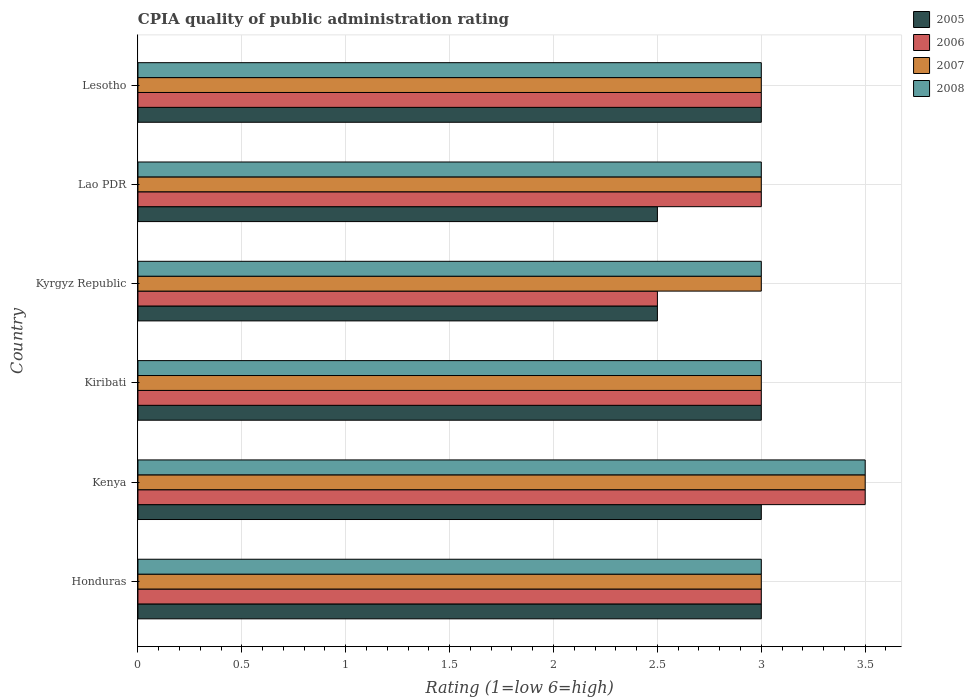How many different coloured bars are there?
Offer a terse response. 4. How many groups of bars are there?
Your answer should be compact. 6. Are the number of bars on each tick of the Y-axis equal?
Your response must be concise. Yes. How many bars are there on the 2nd tick from the top?
Give a very brief answer. 4. How many bars are there on the 2nd tick from the bottom?
Offer a very short reply. 4. What is the label of the 3rd group of bars from the top?
Offer a very short reply. Kyrgyz Republic. In how many cases, is the number of bars for a given country not equal to the number of legend labels?
Your answer should be compact. 0. Across all countries, what is the maximum CPIA rating in 2007?
Provide a short and direct response. 3.5. Across all countries, what is the minimum CPIA rating in 2008?
Your answer should be very brief. 3. In which country was the CPIA rating in 2006 maximum?
Ensure brevity in your answer.  Kenya. In which country was the CPIA rating in 2007 minimum?
Offer a terse response. Honduras. What is the total CPIA rating in 2007 in the graph?
Give a very brief answer. 18.5. What is the difference between the CPIA rating in 2008 in Honduras and the CPIA rating in 2005 in Lesotho?
Give a very brief answer. 0. What is the average CPIA rating in 2005 per country?
Give a very brief answer. 2.83. What is the difference between the CPIA rating in 2005 and CPIA rating in 2007 in Lao PDR?
Keep it short and to the point. -0.5. What is the ratio of the CPIA rating in 2006 in Honduras to that in Kenya?
Provide a short and direct response. 0.86. Is the difference between the CPIA rating in 2005 in Kenya and Kyrgyz Republic greater than the difference between the CPIA rating in 2007 in Kenya and Kyrgyz Republic?
Provide a succinct answer. No. What is the difference between the highest and the second highest CPIA rating in 2005?
Ensure brevity in your answer.  0. In how many countries, is the CPIA rating in 2005 greater than the average CPIA rating in 2005 taken over all countries?
Ensure brevity in your answer.  4. Is it the case that in every country, the sum of the CPIA rating in 2005 and CPIA rating in 2008 is greater than the sum of CPIA rating in 2006 and CPIA rating in 2007?
Offer a terse response. No. What does the 3rd bar from the top in Honduras represents?
Provide a succinct answer. 2006. Are all the bars in the graph horizontal?
Give a very brief answer. Yes. Are the values on the major ticks of X-axis written in scientific E-notation?
Keep it short and to the point. No. Does the graph contain any zero values?
Keep it short and to the point. No. How are the legend labels stacked?
Your answer should be very brief. Vertical. What is the title of the graph?
Offer a terse response. CPIA quality of public administration rating. What is the label or title of the Y-axis?
Keep it short and to the point. Country. What is the Rating (1=low 6=high) in 2006 in Honduras?
Provide a succinct answer. 3. What is the Rating (1=low 6=high) in 2007 in Kenya?
Your answer should be compact. 3.5. What is the Rating (1=low 6=high) of 2008 in Kenya?
Offer a very short reply. 3.5. What is the Rating (1=low 6=high) in 2006 in Kiribati?
Make the answer very short. 3. What is the Rating (1=low 6=high) in 2007 in Kiribati?
Your answer should be compact. 3. What is the Rating (1=low 6=high) of 2008 in Kyrgyz Republic?
Your answer should be very brief. 3. What is the Rating (1=low 6=high) in 2005 in Lao PDR?
Offer a very short reply. 2.5. What is the Rating (1=low 6=high) of 2006 in Lao PDR?
Your answer should be compact. 3. What is the Rating (1=low 6=high) of 2007 in Lesotho?
Your answer should be compact. 3. Across all countries, what is the minimum Rating (1=low 6=high) of 2006?
Your answer should be very brief. 2.5. Across all countries, what is the minimum Rating (1=low 6=high) in 2007?
Provide a succinct answer. 3. Across all countries, what is the minimum Rating (1=low 6=high) in 2008?
Give a very brief answer. 3. What is the total Rating (1=low 6=high) in 2005 in the graph?
Keep it short and to the point. 17. What is the difference between the Rating (1=low 6=high) in 2007 in Honduras and that in Kenya?
Keep it short and to the point. -0.5. What is the difference between the Rating (1=low 6=high) in 2007 in Honduras and that in Kiribati?
Your answer should be compact. 0. What is the difference between the Rating (1=low 6=high) of 2008 in Honduras and that in Kiribati?
Provide a succinct answer. 0. What is the difference between the Rating (1=low 6=high) of 2005 in Honduras and that in Kyrgyz Republic?
Keep it short and to the point. 0.5. What is the difference between the Rating (1=low 6=high) in 2007 in Honduras and that in Kyrgyz Republic?
Offer a terse response. 0. What is the difference between the Rating (1=low 6=high) of 2008 in Honduras and that in Kyrgyz Republic?
Provide a short and direct response. 0. What is the difference between the Rating (1=low 6=high) in 2005 in Honduras and that in Lao PDR?
Offer a very short reply. 0.5. What is the difference between the Rating (1=low 6=high) in 2006 in Honduras and that in Lao PDR?
Offer a terse response. 0. What is the difference between the Rating (1=low 6=high) of 2007 in Honduras and that in Lao PDR?
Give a very brief answer. 0. What is the difference between the Rating (1=low 6=high) in 2007 in Honduras and that in Lesotho?
Offer a very short reply. 0. What is the difference between the Rating (1=low 6=high) of 2005 in Kenya and that in Kiribati?
Make the answer very short. 0. What is the difference between the Rating (1=low 6=high) in 2008 in Kenya and that in Kyrgyz Republic?
Offer a terse response. 0.5. What is the difference between the Rating (1=low 6=high) in 2005 in Kenya and that in Lesotho?
Offer a terse response. 0. What is the difference between the Rating (1=low 6=high) of 2005 in Kiribati and that in Kyrgyz Republic?
Provide a succinct answer. 0.5. What is the difference between the Rating (1=low 6=high) in 2006 in Kiribati and that in Kyrgyz Republic?
Keep it short and to the point. 0.5. What is the difference between the Rating (1=low 6=high) of 2006 in Kiribati and that in Lao PDR?
Your answer should be compact. 0. What is the difference between the Rating (1=low 6=high) in 2008 in Kiribati and that in Lao PDR?
Offer a terse response. 0. What is the difference between the Rating (1=low 6=high) in 2005 in Kiribati and that in Lesotho?
Your answer should be very brief. 0. What is the difference between the Rating (1=low 6=high) of 2006 in Kiribati and that in Lesotho?
Give a very brief answer. 0. What is the difference between the Rating (1=low 6=high) of 2005 in Kyrgyz Republic and that in Lao PDR?
Ensure brevity in your answer.  0. What is the difference between the Rating (1=low 6=high) in 2007 in Kyrgyz Republic and that in Lao PDR?
Offer a very short reply. 0. What is the difference between the Rating (1=low 6=high) of 2005 in Kyrgyz Republic and that in Lesotho?
Give a very brief answer. -0.5. What is the difference between the Rating (1=low 6=high) of 2005 in Honduras and the Rating (1=low 6=high) of 2006 in Kenya?
Make the answer very short. -0.5. What is the difference between the Rating (1=low 6=high) in 2005 in Honduras and the Rating (1=low 6=high) in 2007 in Kenya?
Your answer should be very brief. -0.5. What is the difference between the Rating (1=low 6=high) in 2006 in Honduras and the Rating (1=low 6=high) in 2007 in Kenya?
Offer a very short reply. -0.5. What is the difference between the Rating (1=low 6=high) of 2007 in Honduras and the Rating (1=low 6=high) of 2008 in Kiribati?
Make the answer very short. 0. What is the difference between the Rating (1=low 6=high) in 2005 in Honduras and the Rating (1=low 6=high) in 2006 in Kyrgyz Republic?
Your answer should be very brief. 0.5. What is the difference between the Rating (1=low 6=high) of 2006 in Honduras and the Rating (1=low 6=high) of 2008 in Kyrgyz Republic?
Your response must be concise. 0. What is the difference between the Rating (1=low 6=high) of 2006 in Honduras and the Rating (1=low 6=high) of 2008 in Lao PDR?
Your response must be concise. 0. What is the difference between the Rating (1=low 6=high) of 2007 in Honduras and the Rating (1=low 6=high) of 2008 in Lao PDR?
Your answer should be compact. 0. What is the difference between the Rating (1=low 6=high) of 2005 in Honduras and the Rating (1=low 6=high) of 2006 in Lesotho?
Your answer should be very brief. 0. What is the difference between the Rating (1=low 6=high) of 2005 in Honduras and the Rating (1=low 6=high) of 2007 in Lesotho?
Make the answer very short. 0. What is the difference between the Rating (1=low 6=high) of 2005 in Honduras and the Rating (1=low 6=high) of 2008 in Lesotho?
Ensure brevity in your answer.  0. What is the difference between the Rating (1=low 6=high) in 2006 in Honduras and the Rating (1=low 6=high) in 2007 in Lesotho?
Ensure brevity in your answer.  0. What is the difference between the Rating (1=low 6=high) of 2006 in Honduras and the Rating (1=low 6=high) of 2008 in Lesotho?
Give a very brief answer. 0. What is the difference between the Rating (1=low 6=high) in 2007 in Honduras and the Rating (1=low 6=high) in 2008 in Lesotho?
Provide a short and direct response. 0. What is the difference between the Rating (1=low 6=high) of 2005 in Kenya and the Rating (1=low 6=high) of 2008 in Kiribati?
Provide a succinct answer. 0. What is the difference between the Rating (1=low 6=high) in 2005 in Kenya and the Rating (1=low 6=high) in 2006 in Kyrgyz Republic?
Offer a terse response. 0.5. What is the difference between the Rating (1=low 6=high) of 2005 in Kenya and the Rating (1=low 6=high) of 2007 in Kyrgyz Republic?
Your answer should be very brief. 0. What is the difference between the Rating (1=low 6=high) in 2005 in Kenya and the Rating (1=low 6=high) in 2008 in Kyrgyz Republic?
Keep it short and to the point. 0. What is the difference between the Rating (1=low 6=high) of 2006 in Kenya and the Rating (1=low 6=high) of 2007 in Kyrgyz Republic?
Keep it short and to the point. 0.5. What is the difference between the Rating (1=low 6=high) of 2006 in Kenya and the Rating (1=low 6=high) of 2008 in Kyrgyz Republic?
Provide a succinct answer. 0.5. What is the difference between the Rating (1=low 6=high) in 2006 in Kenya and the Rating (1=low 6=high) in 2007 in Lao PDR?
Provide a succinct answer. 0.5. What is the difference between the Rating (1=low 6=high) of 2007 in Kenya and the Rating (1=low 6=high) of 2008 in Lao PDR?
Provide a short and direct response. 0.5. What is the difference between the Rating (1=low 6=high) of 2006 in Kenya and the Rating (1=low 6=high) of 2008 in Lesotho?
Offer a terse response. 0.5. What is the difference between the Rating (1=low 6=high) of 2005 in Kiribati and the Rating (1=low 6=high) of 2006 in Kyrgyz Republic?
Make the answer very short. 0.5. What is the difference between the Rating (1=low 6=high) of 2005 in Kiribati and the Rating (1=low 6=high) of 2008 in Kyrgyz Republic?
Give a very brief answer. 0. What is the difference between the Rating (1=low 6=high) of 2006 in Kiribati and the Rating (1=low 6=high) of 2007 in Kyrgyz Republic?
Make the answer very short. 0. What is the difference between the Rating (1=low 6=high) of 2007 in Kiribati and the Rating (1=low 6=high) of 2008 in Kyrgyz Republic?
Provide a short and direct response. 0. What is the difference between the Rating (1=low 6=high) in 2005 in Kiribati and the Rating (1=low 6=high) in 2006 in Lao PDR?
Give a very brief answer. 0. What is the difference between the Rating (1=low 6=high) in 2007 in Kiribati and the Rating (1=low 6=high) in 2008 in Lao PDR?
Keep it short and to the point. 0. What is the difference between the Rating (1=low 6=high) of 2005 in Kiribati and the Rating (1=low 6=high) of 2008 in Lesotho?
Your answer should be compact. 0. What is the difference between the Rating (1=low 6=high) of 2007 in Kiribati and the Rating (1=low 6=high) of 2008 in Lesotho?
Keep it short and to the point. 0. What is the difference between the Rating (1=low 6=high) of 2005 in Kyrgyz Republic and the Rating (1=low 6=high) of 2007 in Lao PDR?
Make the answer very short. -0.5. What is the difference between the Rating (1=low 6=high) of 2005 in Kyrgyz Republic and the Rating (1=low 6=high) of 2008 in Lao PDR?
Make the answer very short. -0.5. What is the difference between the Rating (1=low 6=high) of 2006 in Kyrgyz Republic and the Rating (1=low 6=high) of 2007 in Lao PDR?
Offer a terse response. -0.5. What is the difference between the Rating (1=low 6=high) in 2006 in Kyrgyz Republic and the Rating (1=low 6=high) in 2008 in Lao PDR?
Make the answer very short. -0.5. What is the difference between the Rating (1=low 6=high) of 2007 in Kyrgyz Republic and the Rating (1=low 6=high) of 2008 in Lao PDR?
Provide a short and direct response. 0. What is the difference between the Rating (1=low 6=high) of 2005 in Kyrgyz Republic and the Rating (1=low 6=high) of 2006 in Lesotho?
Ensure brevity in your answer.  -0.5. What is the difference between the Rating (1=low 6=high) in 2005 in Kyrgyz Republic and the Rating (1=low 6=high) in 2008 in Lesotho?
Keep it short and to the point. -0.5. What is the difference between the Rating (1=low 6=high) of 2006 in Kyrgyz Republic and the Rating (1=low 6=high) of 2007 in Lesotho?
Provide a succinct answer. -0.5. What is the difference between the Rating (1=low 6=high) of 2005 in Lao PDR and the Rating (1=low 6=high) of 2007 in Lesotho?
Ensure brevity in your answer.  -0.5. What is the difference between the Rating (1=low 6=high) of 2005 in Lao PDR and the Rating (1=low 6=high) of 2008 in Lesotho?
Offer a very short reply. -0.5. What is the difference between the Rating (1=low 6=high) in 2006 in Lao PDR and the Rating (1=low 6=high) in 2007 in Lesotho?
Provide a short and direct response. 0. What is the difference between the Rating (1=low 6=high) of 2006 in Lao PDR and the Rating (1=low 6=high) of 2008 in Lesotho?
Ensure brevity in your answer.  0. What is the difference between the Rating (1=low 6=high) of 2007 in Lao PDR and the Rating (1=low 6=high) of 2008 in Lesotho?
Your response must be concise. 0. What is the average Rating (1=low 6=high) of 2005 per country?
Keep it short and to the point. 2.83. What is the average Rating (1=low 6=high) in 2007 per country?
Give a very brief answer. 3.08. What is the average Rating (1=low 6=high) of 2008 per country?
Ensure brevity in your answer.  3.08. What is the difference between the Rating (1=low 6=high) in 2005 and Rating (1=low 6=high) in 2006 in Honduras?
Your answer should be compact. 0. What is the difference between the Rating (1=low 6=high) in 2005 and Rating (1=low 6=high) in 2007 in Honduras?
Your response must be concise. 0. What is the difference between the Rating (1=low 6=high) in 2006 and Rating (1=low 6=high) in 2008 in Honduras?
Provide a short and direct response. 0. What is the difference between the Rating (1=low 6=high) of 2005 and Rating (1=low 6=high) of 2006 in Kenya?
Give a very brief answer. -0.5. What is the difference between the Rating (1=low 6=high) of 2006 and Rating (1=low 6=high) of 2007 in Kenya?
Your answer should be compact. 0. What is the difference between the Rating (1=low 6=high) of 2005 and Rating (1=low 6=high) of 2006 in Kiribati?
Your answer should be very brief. 0. What is the difference between the Rating (1=low 6=high) in 2005 and Rating (1=low 6=high) in 2007 in Kiribati?
Offer a very short reply. 0. What is the difference between the Rating (1=low 6=high) of 2007 and Rating (1=low 6=high) of 2008 in Kiribati?
Your response must be concise. 0. What is the difference between the Rating (1=low 6=high) in 2006 and Rating (1=low 6=high) in 2007 in Kyrgyz Republic?
Offer a very short reply. -0.5. What is the difference between the Rating (1=low 6=high) of 2005 and Rating (1=low 6=high) of 2006 in Lao PDR?
Your answer should be compact. -0.5. What is the difference between the Rating (1=low 6=high) of 2005 and Rating (1=low 6=high) of 2007 in Lao PDR?
Give a very brief answer. -0.5. What is the difference between the Rating (1=low 6=high) in 2005 and Rating (1=low 6=high) in 2008 in Lao PDR?
Keep it short and to the point. -0.5. What is the difference between the Rating (1=low 6=high) of 2007 and Rating (1=low 6=high) of 2008 in Lao PDR?
Provide a succinct answer. 0. What is the difference between the Rating (1=low 6=high) of 2005 and Rating (1=low 6=high) of 2006 in Lesotho?
Your answer should be compact. 0. What is the difference between the Rating (1=low 6=high) of 2006 and Rating (1=low 6=high) of 2008 in Lesotho?
Offer a terse response. 0. What is the difference between the Rating (1=low 6=high) in 2007 and Rating (1=low 6=high) in 2008 in Lesotho?
Keep it short and to the point. 0. What is the ratio of the Rating (1=low 6=high) of 2005 in Honduras to that in Kenya?
Your response must be concise. 1. What is the ratio of the Rating (1=low 6=high) of 2005 in Honduras to that in Kiribati?
Keep it short and to the point. 1. What is the ratio of the Rating (1=low 6=high) in 2008 in Honduras to that in Kiribati?
Ensure brevity in your answer.  1. What is the ratio of the Rating (1=low 6=high) of 2005 in Honduras to that in Lao PDR?
Your answer should be compact. 1.2. What is the ratio of the Rating (1=low 6=high) in 2007 in Honduras to that in Lao PDR?
Your answer should be very brief. 1. What is the ratio of the Rating (1=low 6=high) of 2005 in Honduras to that in Lesotho?
Give a very brief answer. 1. What is the ratio of the Rating (1=low 6=high) in 2006 in Honduras to that in Lesotho?
Offer a very short reply. 1. What is the ratio of the Rating (1=low 6=high) of 2006 in Kenya to that in Kiribati?
Your answer should be very brief. 1.17. What is the ratio of the Rating (1=low 6=high) of 2007 in Kenya to that in Kiribati?
Offer a very short reply. 1.17. What is the ratio of the Rating (1=low 6=high) in 2005 in Kenya to that in Lao PDR?
Provide a short and direct response. 1.2. What is the ratio of the Rating (1=low 6=high) in 2007 in Kenya to that in Lao PDR?
Provide a succinct answer. 1.17. What is the ratio of the Rating (1=low 6=high) of 2008 in Kenya to that in Lao PDR?
Provide a succinct answer. 1.17. What is the ratio of the Rating (1=low 6=high) in 2007 in Kenya to that in Lesotho?
Your answer should be compact. 1.17. What is the ratio of the Rating (1=low 6=high) of 2005 in Kiribati to that in Kyrgyz Republic?
Provide a succinct answer. 1.2. What is the ratio of the Rating (1=low 6=high) in 2006 in Kiribati to that in Kyrgyz Republic?
Offer a very short reply. 1.2. What is the ratio of the Rating (1=low 6=high) in 2007 in Kiribati to that in Kyrgyz Republic?
Your response must be concise. 1. What is the ratio of the Rating (1=low 6=high) of 2006 in Kiribati to that in Lao PDR?
Your response must be concise. 1. What is the ratio of the Rating (1=low 6=high) in 2007 in Kiribati to that in Lao PDR?
Provide a succinct answer. 1. What is the ratio of the Rating (1=low 6=high) of 2007 in Kiribati to that in Lesotho?
Ensure brevity in your answer.  1. What is the ratio of the Rating (1=low 6=high) of 2005 in Kyrgyz Republic to that in Lao PDR?
Give a very brief answer. 1. What is the ratio of the Rating (1=low 6=high) in 2005 in Kyrgyz Republic to that in Lesotho?
Offer a very short reply. 0.83. What is the ratio of the Rating (1=low 6=high) in 2006 in Kyrgyz Republic to that in Lesotho?
Your answer should be very brief. 0.83. What is the ratio of the Rating (1=low 6=high) of 2008 in Kyrgyz Republic to that in Lesotho?
Give a very brief answer. 1. What is the ratio of the Rating (1=low 6=high) of 2005 in Lao PDR to that in Lesotho?
Ensure brevity in your answer.  0.83. What is the ratio of the Rating (1=low 6=high) in 2008 in Lao PDR to that in Lesotho?
Provide a short and direct response. 1. What is the difference between the highest and the second highest Rating (1=low 6=high) of 2007?
Your answer should be compact. 0.5. What is the difference between the highest and the second highest Rating (1=low 6=high) in 2008?
Keep it short and to the point. 0.5. What is the difference between the highest and the lowest Rating (1=low 6=high) of 2005?
Make the answer very short. 0.5. What is the difference between the highest and the lowest Rating (1=low 6=high) of 2006?
Your answer should be compact. 1. 